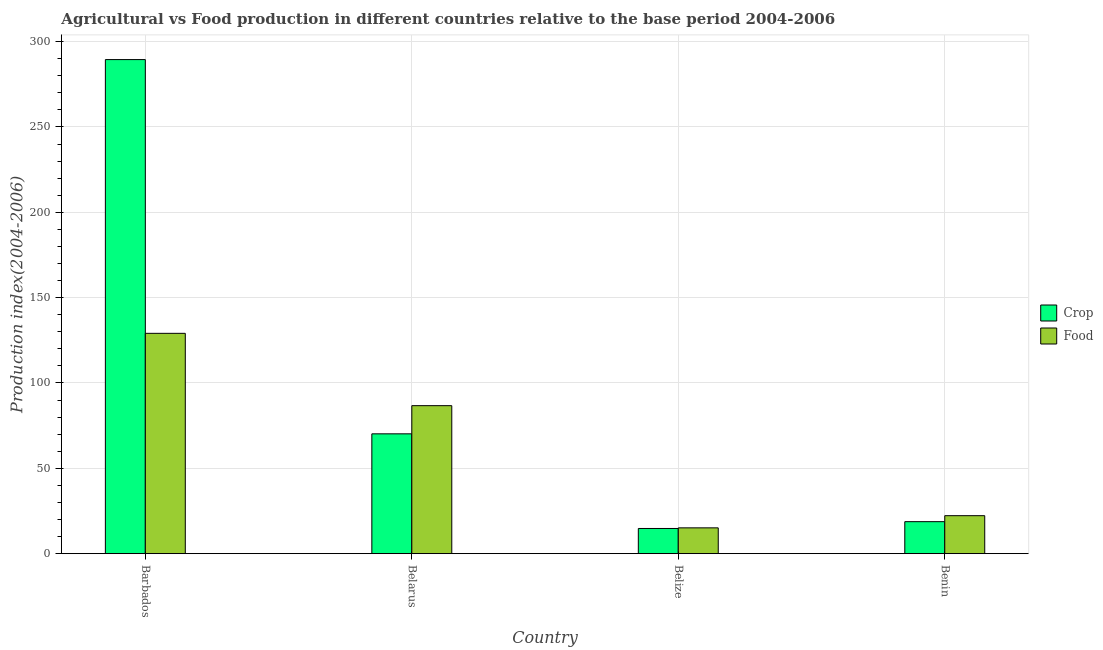How many different coloured bars are there?
Give a very brief answer. 2. How many groups of bars are there?
Offer a very short reply. 4. Are the number of bars per tick equal to the number of legend labels?
Your answer should be compact. Yes. Are the number of bars on each tick of the X-axis equal?
Offer a terse response. Yes. What is the label of the 3rd group of bars from the left?
Ensure brevity in your answer.  Belize. What is the crop production index in Benin?
Keep it short and to the point. 18.74. Across all countries, what is the maximum food production index?
Your answer should be very brief. 129.08. Across all countries, what is the minimum crop production index?
Give a very brief answer. 14.75. In which country was the crop production index maximum?
Give a very brief answer. Barbados. In which country was the food production index minimum?
Provide a short and direct response. Belize. What is the total food production index in the graph?
Make the answer very short. 253.13. What is the difference between the food production index in Belarus and that in Benin?
Offer a very short reply. 64.46. What is the difference between the crop production index in Belarus and the food production index in Barbados?
Ensure brevity in your answer.  -58.88. What is the average food production index per country?
Make the answer very short. 63.28. What is the difference between the crop production index and food production index in Belize?
Your answer should be very brief. -0.36. What is the ratio of the food production index in Belarus to that in Benin?
Offer a very short reply. 3.9. Is the difference between the crop production index in Belarus and Benin greater than the difference between the food production index in Belarus and Benin?
Offer a terse response. No. What is the difference between the highest and the second highest crop production index?
Provide a short and direct response. 219.28. What is the difference between the highest and the lowest crop production index?
Offer a very short reply. 274.73. In how many countries, is the food production index greater than the average food production index taken over all countries?
Make the answer very short. 2. Is the sum of the food production index in Belarus and Belize greater than the maximum crop production index across all countries?
Make the answer very short. No. What does the 2nd bar from the left in Belize represents?
Provide a succinct answer. Food. What does the 1st bar from the right in Belize represents?
Your response must be concise. Food. How many bars are there?
Ensure brevity in your answer.  8. Are all the bars in the graph horizontal?
Your answer should be very brief. No. How many countries are there in the graph?
Provide a succinct answer. 4. What is the difference between two consecutive major ticks on the Y-axis?
Provide a succinct answer. 50. How many legend labels are there?
Your response must be concise. 2. What is the title of the graph?
Offer a terse response. Agricultural vs Food production in different countries relative to the base period 2004-2006. What is the label or title of the X-axis?
Your answer should be compact. Country. What is the label or title of the Y-axis?
Give a very brief answer. Production index(2004-2006). What is the Production index(2004-2006) of Crop in Barbados?
Keep it short and to the point. 289.48. What is the Production index(2004-2006) of Food in Barbados?
Your answer should be compact. 129.08. What is the Production index(2004-2006) in Crop in Belarus?
Give a very brief answer. 70.2. What is the Production index(2004-2006) of Food in Belarus?
Your response must be concise. 86.7. What is the Production index(2004-2006) of Crop in Belize?
Give a very brief answer. 14.75. What is the Production index(2004-2006) in Food in Belize?
Your answer should be compact. 15.11. What is the Production index(2004-2006) in Crop in Benin?
Ensure brevity in your answer.  18.74. What is the Production index(2004-2006) of Food in Benin?
Your response must be concise. 22.24. Across all countries, what is the maximum Production index(2004-2006) of Crop?
Offer a terse response. 289.48. Across all countries, what is the maximum Production index(2004-2006) of Food?
Ensure brevity in your answer.  129.08. Across all countries, what is the minimum Production index(2004-2006) of Crop?
Your answer should be compact. 14.75. Across all countries, what is the minimum Production index(2004-2006) in Food?
Keep it short and to the point. 15.11. What is the total Production index(2004-2006) in Crop in the graph?
Offer a very short reply. 393.17. What is the total Production index(2004-2006) in Food in the graph?
Keep it short and to the point. 253.13. What is the difference between the Production index(2004-2006) of Crop in Barbados and that in Belarus?
Make the answer very short. 219.28. What is the difference between the Production index(2004-2006) in Food in Barbados and that in Belarus?
Make the answer very short. 42.38. What is the difference between the Production index(2004-2006) of Crop in Barbados and that in Belize?
Provide a short and direct response. 274.73. What is the difference between the Production index(2004-2006) in Food in Barbados and that in Belize?
Offer a terse response. 113.97. What is the difference between the Production index(2004-2006) of Crop in Barbados and that in Benin?
Offer a very short reply. 270.74. What is the difference between the Production index(2004-2006) in Food in Barbados and that in Benin?
Offer a very short reply. 106.84. What is the difference between the Production index(2004-2006) of Crop in Belarus and that in Belize?
Offer a terse response. 55.45. What is the difference between the Production index(2004-2006) of Food in Belarus and that in Belize?
Ensure brevity in your answer.  71.59. What is the difference between the Production index(2004-2006) in Crop in Belarus and that in Benin?
Provide a short and direct response. 51.46. What is the difference between the Production index(2004-2006) of Food in Belarus and that in Benin?
Give a very brief answer. 64.46. What is the difference between the Production index(2004-2006) of Crop in Belize and that in Benin?
Offer a very short reply. -3.99. What is the difference between the Production index(2004-2006) in Food in Belize and that in Benin?
Ensure brevity in your answer.  -7.13. What is the difference between the Production index(2004-2006) of Crop in Barbados and the Production index(2004-2006) of Food in Belarus?
Give a very brief answer. 202.78. What is the difference between the Production index(2004-2006) of Crop in Barbados and the Production index(2004-2006) of Food in Belize?
Your answer should be compact. 274.37. What is the difference between the Production index(2004-2006) in Crop in Barbados and the Production index(2004-2006) in Food in Benin?
Provide a short and direct response. 267.24. What is the difference between the Production index(2004-2006) in Crop in Belarus and the Production index(2004-2006) in Food in Belize?
Your answer should be very brief. 55.09. What is the difference between the Production index(2004-2006) of Crop in Belarus and the Production index(2004-2006) of Food in Benin?
Ensure brevity in your answer.  47.96. What is the difference between the Production index(2004-2006) of Crop in Belize and the Production index(2004-2006) of Food in Benin?
Your answer should be very brief. -7.49. What is the average Production index(2004-2006) in Crop per country?
Your answer should be compact. 98.29. What is the average Production index(2004-2006) in Food per country?
Offer a very short reply. 63.28. What is the difference between the Production index(2004-2006) of Crop and Production index(2004-2006) of Food in Barbados?
Offer a very short reply. 160.4. What is the difference between the Production index(2004-2006) in Crop and Production index(2004-2006) in Food in Belarus?
Keep it short and to the point. -16.5. What is the difference between the Production index(2004-2006) in Crop and Production index(2004-2006) in Food in Belize?
Your response must be concise. -0.36. What is the difference between the Production index(2004-2006) of Crop and Production index(2004-2006) of Food in Benin?
Keep it short and to the point. -3.5. What is the ratio of the Production index(2004-2006) of Crop in Barbados to that in Belarus?
Ensure brevity in your answer.  4.12. What is the ratio of the Production index(2004-2006) of Food in Barbados to that in Belarus?
Provide a succinct answer. 1.49. What is the ratio of the Production index(2004-2006) of Crop in Barbados to that in Belize?
Your response must be concise. 19.63. What is the ratio of the Production index(2004-2006) of Food in Barbados to that in Belize?
Offer a very short reply. 8.54. What is the ratio of the Production index(2004-2006) in Crop in Barbados to that in Benin?
Provide a short and direct response. 15.45. What is the ratio of the Production index(2004-2006) in Food in Barbados to that in Benin?
Your answer should be compact. 5.8. What is the ratio of the Production index(2004-2006) of Crop in Belarus to that in Belize?
Provide a short and direct response. 4.76. What is the ratio of the Production index(2004-2006) in Food in Belarus to that in Belize?
Provide a succinct answer. 5.74. What is the ratio of the Production index(2004-2006) of Crop in Belarus to that in Benin?
Make the answer very short. 3.75. What is the ratio of the Production index(2004-2006) in Food in Belarus to that in Benin?
Provide a short and direct response. 3.9. What is the ratio of the Production index(2004-2006) in Crop in Belize to that in Benin?
Ensure brevity in your answer.  0.79. What is the ratio of the Production index(2004-2006) of Food in Belize to that in Benin?
Your answer should be compact. 0.68. What is the difference between the highest and the second highest Production index(2004-2006) in Crop?
Provide a succinct answer. 219.28. What is the difference between the highest and the second highest Production index(2004-2006) of Food?
Offer a terse response. 42.38. What is the difference between the highest and the lowest Production index(2004-2006) in Crop?
Your answer should be compact. 274.73. What is the difference between the highest and the lowest Production index(2004-2006) of Food?
Offer a very short reply. 113.97. 